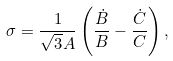Convert formula to latex. <formula><loc_0><loc_0><loc_500><loc_500>\sigma = \frac { 1 } { \sqrt { 3 } A } \left ( \frac { \dot { B } } { B } - \frac { \dot { C } } { C } \right ) ,</formula> 